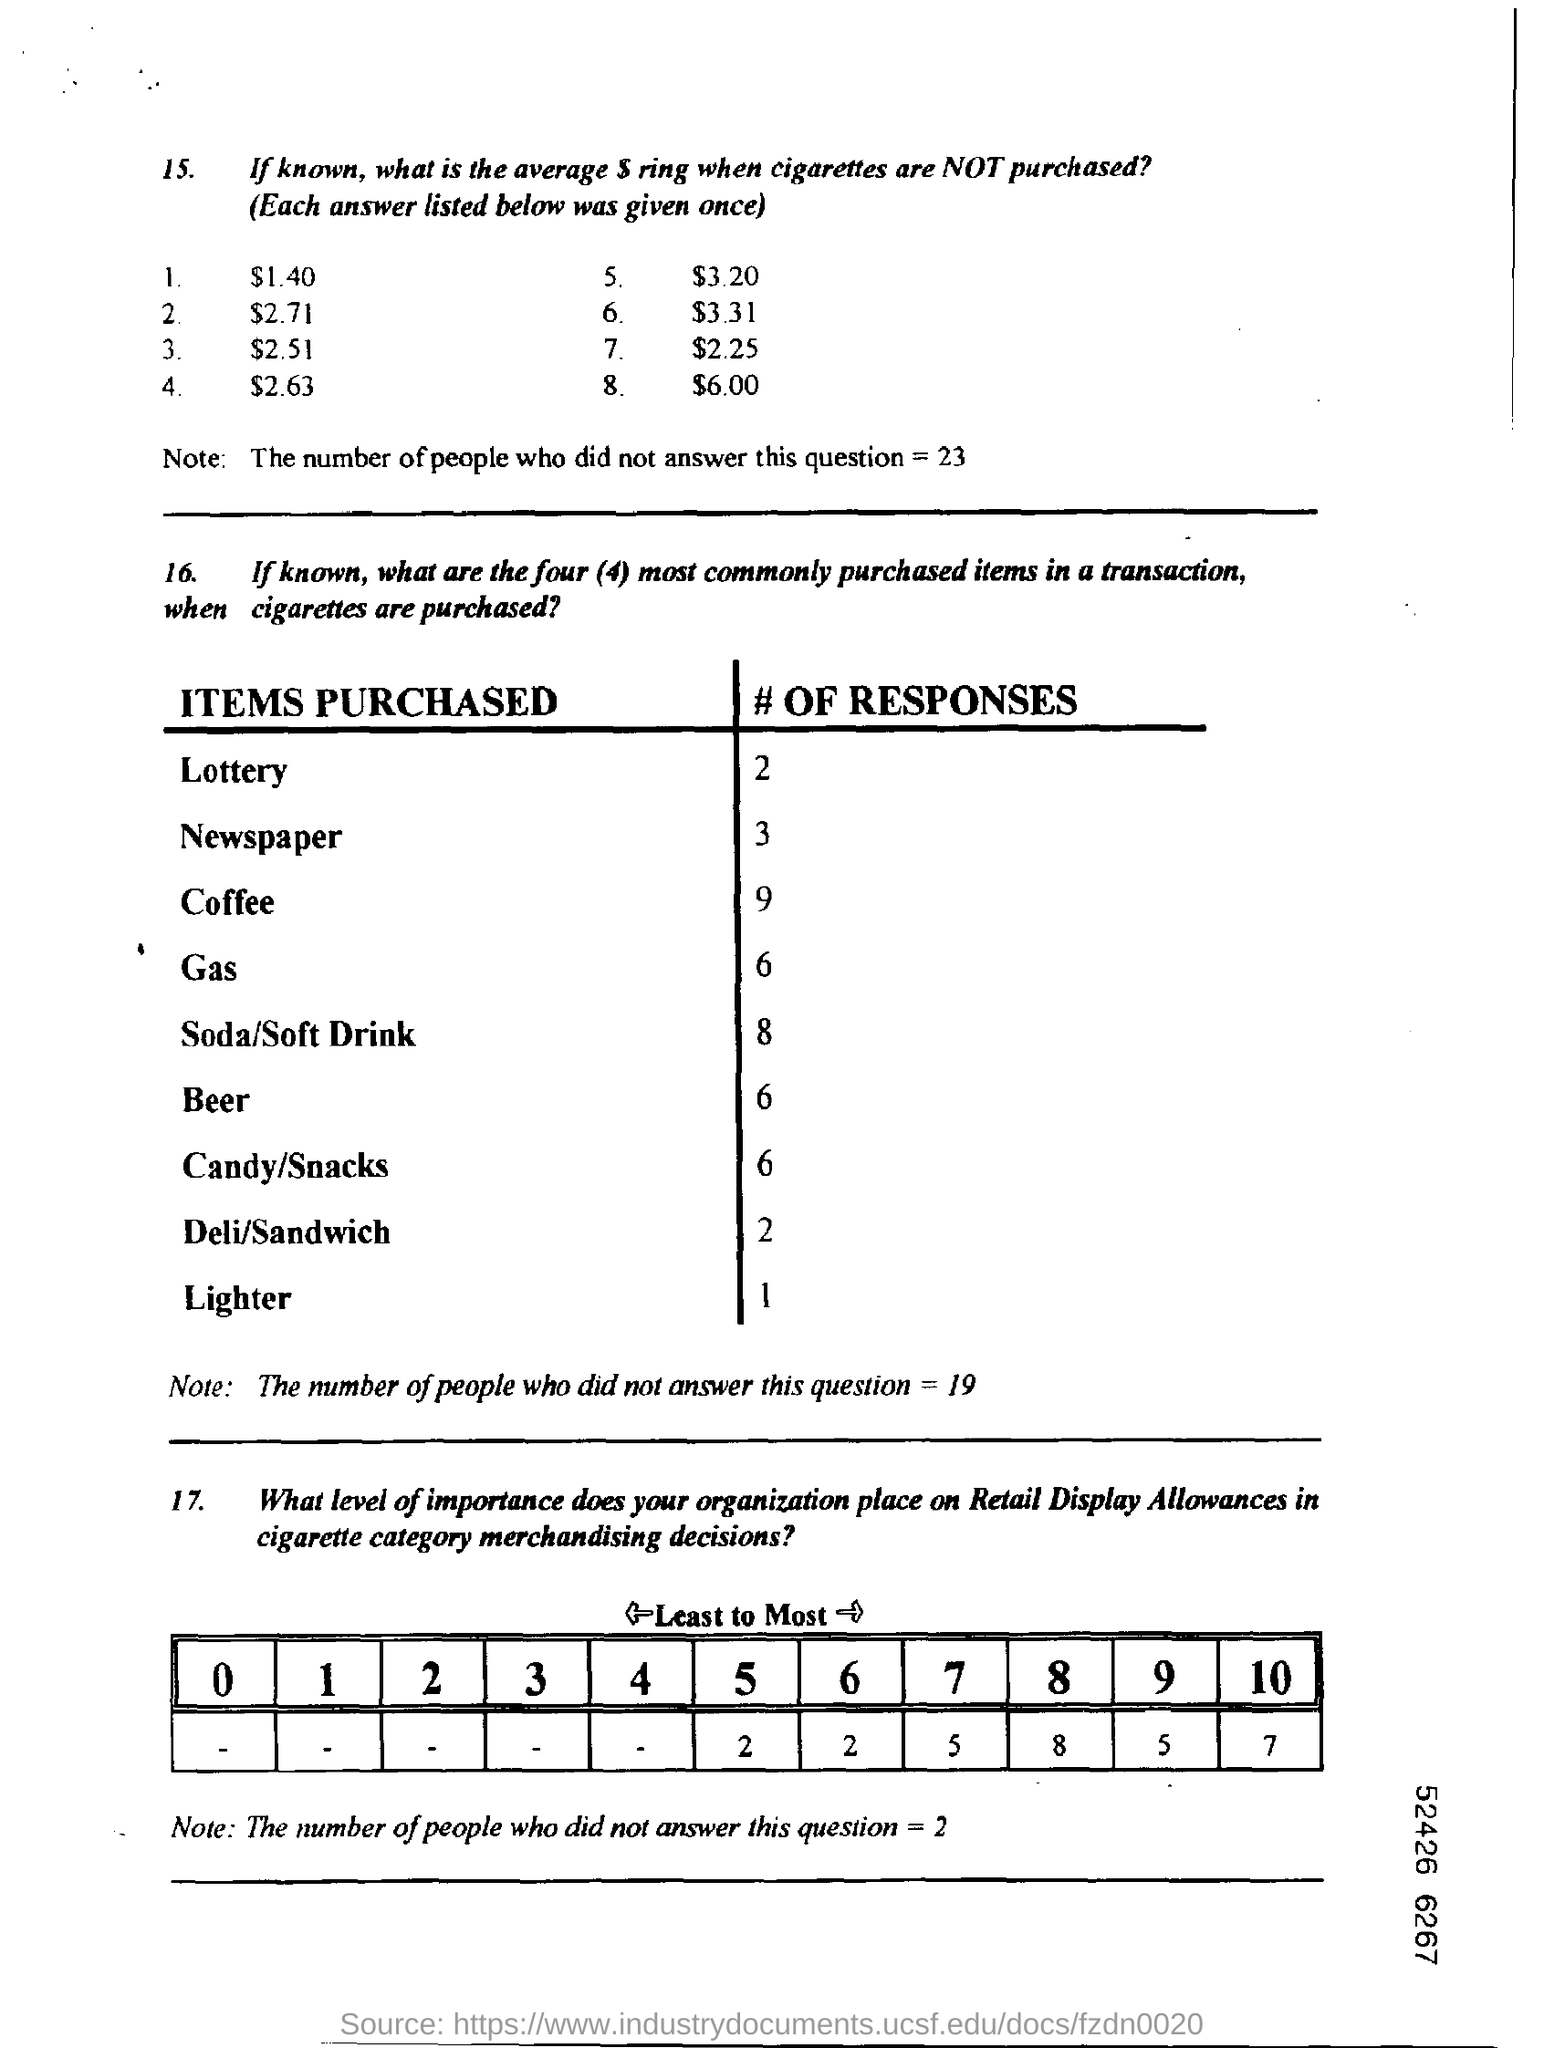Draw attention to some important aspects in this diagram. Nine responses were received from coffee in the survey. 